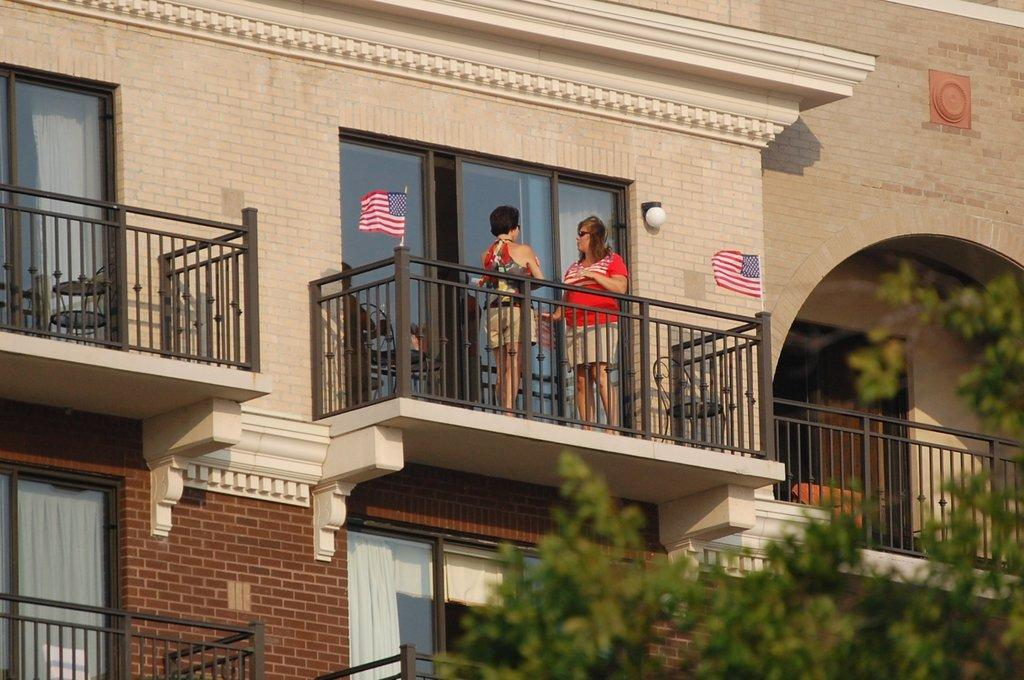What type of structures can be seen in the image? There are buildings in the image. What decorative or symbolic objects are present in the image? There are flags in the image. What architectural feature can be seen in the image? There is railing in the image. What openings are visible in the buildings? There are windows in the image. What type of vegetation is present in the image? There is a tree in the image. How many people are visible in the image? There are two women standing in the image. What type of cloud can be seen in the image? There is no cloud present in the image. What tool is being used by one of the women to make an adjustment in the image? There is no tool or adjustment being made by either of the women in the image. 